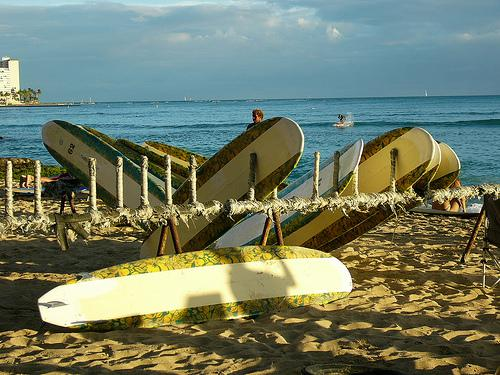Question: who is in the water?
Choices:
A. Children.
B. Wife.
C. A surfer.
D. Husband.
Answer with the letter. Answer: C Question: what color is the sand?
Choices:
A. White.
B. Pink.
C. Yellow.
D. Brown.
Answer with the letter. Answer: D Question: who is walking on the beach?
Choices:
A. Dog.
B. Cat.
C. A guy.
D. Man.
Answer with the letter. Answer: C Question: how many surfboards are there?
Choices:
A. Three.
B. Two.
C. More than five.
D. Seven.
Answer with the letter. Answer: C 